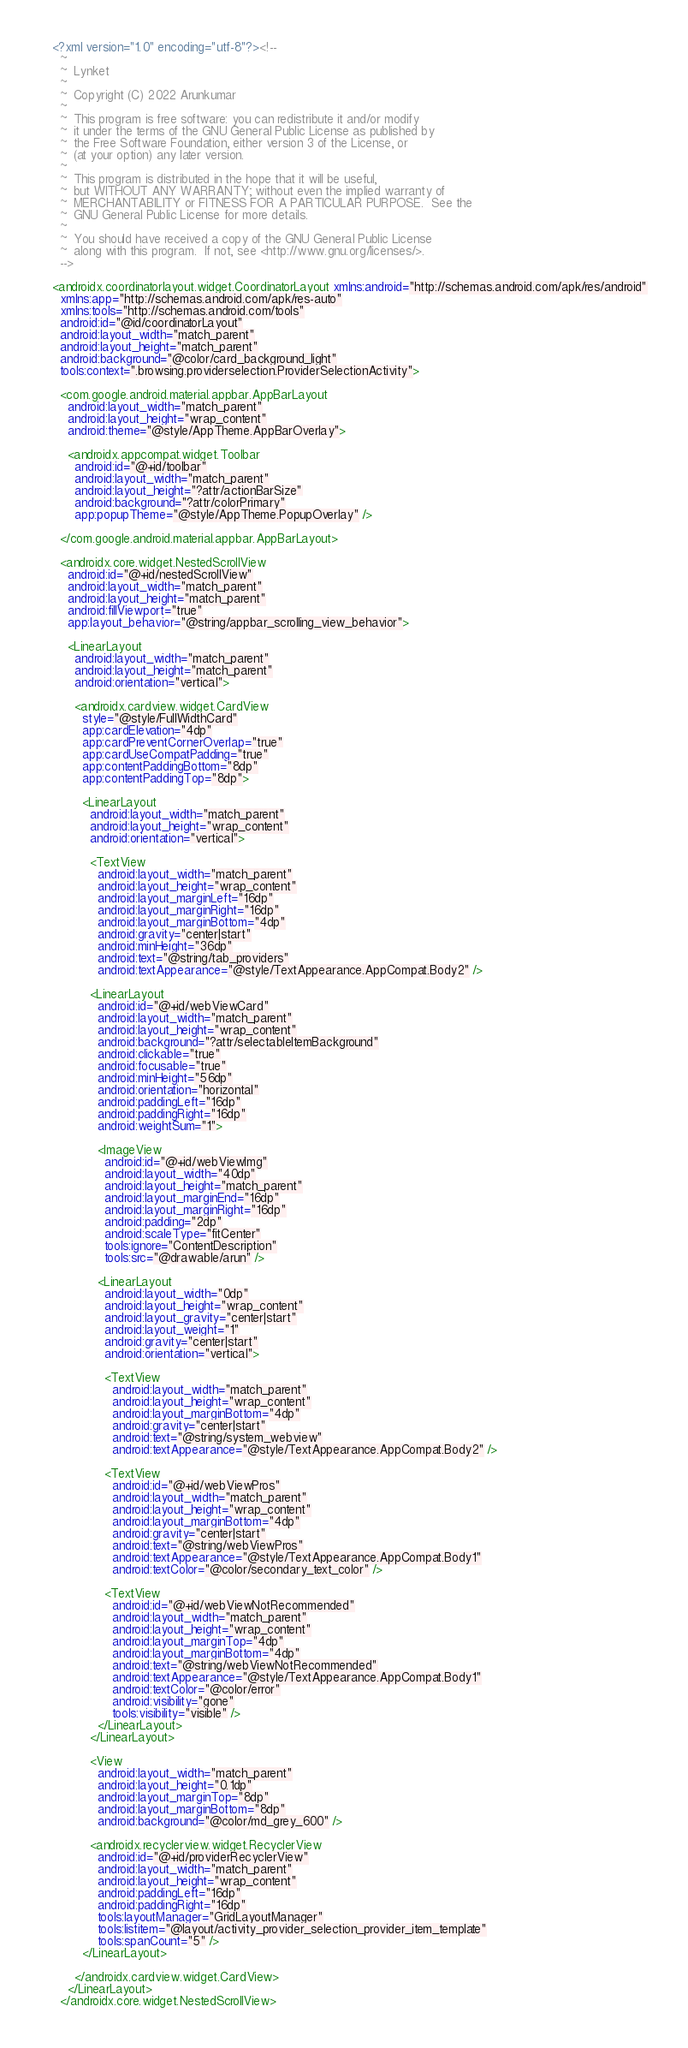Convert code to text. <code><loc_0><loc_0><loc_500><loc_500><_XML_><?xml version="1.0" encoding="utf-8"?><!--
  ~
  ~  Lynket
  ~
  ~  Copyright (C) 2022 Arunkumar
  ~
  ~  This program is free software: you can redistribute it and/or modify
  ~  it under the terms of the GNU General Public License as published by
  ~  the Free Software Foundation, either version 3 of the License, or
  ~  (at your option) any later version.
  ~
  ~  This program is distributed in the hope that it will be useful,
  ~  but WITHOUT ANY WARRANTY; without even the implied warranty of
  ~  MERCHANTABILITY or FITNESS FOR A PARTICULAR PURPOSE.  See the
  ~  GNU General Public License for more details.
  ~
  ~  You should have received a copy of the GNU General Public License
  ~  along with this program.  If not, see <http://www.gnu.org/licenses/>.
  -->

<androidx.coordinatorlayout.widget.CoordinatorLayout xmlns:android="http://schemas.android.com/apk/res/android"
  xmlns:app="http://schemas.android.com/apk/res-auto"
  xmlns:tools="http://schemas.android.com/tools"
  android:id="@id/coordinatorLayout"
  android:layout_width="match_parent"
  android:layout_height="match_parent"
  android:background="@color/card_background_light"
  tools:context=".browsing.providerselection.ProviderSelectionActivity">

  <com.google.android.material.appbar.AppBarLayout
    android:layout_width="match_parent"
    android:layout_height="wrap_content"
    android:theme="@style/AppTheme.AppBarOverlay">

    <androidx.appcompat.widget.Toolbar
      android:id="@+id/toolbar"
      android:layout_width="match_parent"
      android:layout_height="?attr/actionBarSize"
      android:background="?attr/colorPrimary"
      app:popupTheme="@style/AppTheme.PopupOverlay" />

  </com.google.android.material.appbar.AppBarLayout>

  <androidx.core.widget.NestedScrollView
    android:id="@+id/nestedScrollView"
    android:layout_width="match_parent"
    android:layout_height="match_parent"
    android:fillViewport="true"
    app:layout_behavior="@string/appbar_scrolling_view_behavior">

    <LinearLayout
      android:layout_width="match_parent"
      android:layout_height="match_parent"
      android:orientation="vertical">

      <androidx.cardview.widget.CardView
        style="@style/FullWidthCard"
        app:cardElevation="4dp"
        app:cardPreventCornerOverlap="true"
        app:cardUseCompatPadding="true"
        app:contentPaddingBottom="8dp"
        app:contentPaddingTop="8dp">

        <LinearLayout
          android:layout_width="match_parent"
          android:layout_height="wrap_content"
          android:orientation="vertical">

          <TextView
            android:layout_width="match_parent"
            android:layout_height="wrap_content"
            android:layout_marginLeft="16dp"
            android:layout_marginRight="16dp"
            android:layout_marginBottom="4dp"
            android:gravity="center|start"
            android:minHeight="36dp"
            android:text="@string/tab_providers"
            android:textAppearance="@style/TextAppearance.AppCompat.Body2" />

          <LinearLayout
            android:id="@+id/webViewCard"
            android:layout_width="match_parent"
            android:layout_height="wrap_content"
            android:background="?attr/selectableItemBackground"
            android:clickable="true"
            android:focusable="true"
            android:minHeight="56dp"
            android:orientation="horizontal"
            android:paddingLeft="16dp"
            android:paddingRight="16dp"
            android:weightSum="1">

            <ImageView
              android:id="@+id/webViewImg"
              android:layout_width="40dp"
              android:layout_height="match_parent"
              android:layout_marginEnd="16dp"
              android:layout_marginRight="16dp"
              android:padding="2dp"
              android:scaleType="fitCenter"
              tools:ignore="ContentDescription"
              tools:src="@drawable/arun" />

            <LinearLayout
              android:layout_width="0dp"
              android:layout_height="wrap_content"
              android:layout_gravity="center|start"
              android:layout_weight="1"
              android:gravity="center|start"
              android:orientation="vertical">

              <TextView
                android:layout_width="match_parent"
                android:layout_height="wrap_content"
                android:layout_marginBottom="4dp"
                android:gravity="center|start"
                android:text="@string/system_webview"
                android:textAppearance="@style/TextAppearance.AppCompat.Body2" />

              <TextView
                android:id="@+id/webViewPros"
                android:layout_width="match_parent"
                android:layout_height="wrap_content"
                android:layout_marginBottom="4dp"
                android:gravity="center|start"
                android:text="@string/webViewPros"
                android:textAppearance="@style/TextAppearance.AppCompat.Body1"
                android:textColor="@color/secondary_text_color" />

              <TextView
                android:id="@+id/webViewNotRecommended"
                android:layout_width="match_parent"
                android:layout_height="wrap_content"
                android:layout_marginTop="4dp"
                android:layout_marginBottom="4dp"
                android:text="@string/webViewNotRecommended"
                android:textAppearance="@style/TextAppearance.AppCompat.Body1"
                android:textColor="@color/error"
                android:visibility="gone"
                tools:visibility="visible" />
            </LinearLayout>
          </LinearLayout>

          <View
            android:layout_width="match_parent"
            android:layout_height="0.1dp"
            android:layout_marginTop="8dp"
            android:layout_marginBottom="8dp"
            android:background="@color/md_grey_600" />

          <androidx.recyclerview.widget.RecyclerView
            android:id="@+id/providerRecyclerView"
            android:layout_width="match_parent"
            android:layout_height="wrap_content"
            android:paddingLeft="16dp"
            android:paddingRight="16dp"
            tools:layoutManager="GridLayoutManager"
            tools:listitem="@layout/activity_provider_selection_provider_item_template"
            tools:spanCount="5" />
        </LinearLayout>

      </androidx.cardview.widget.CardView>
    </LinearLayout>
  </androidx.core.widget.NestedScrollView></code> 